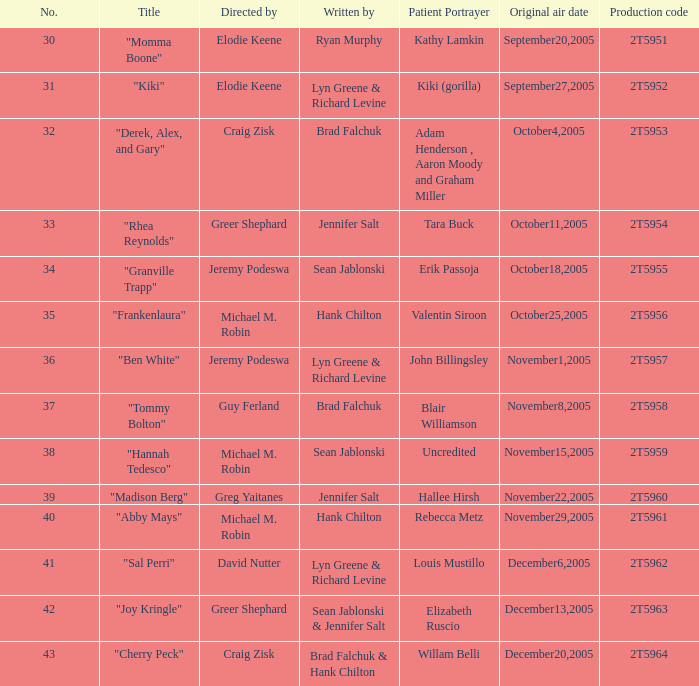What is the production number for the episode with the patient role portrayed by kathy lamkin? 2T5951. 